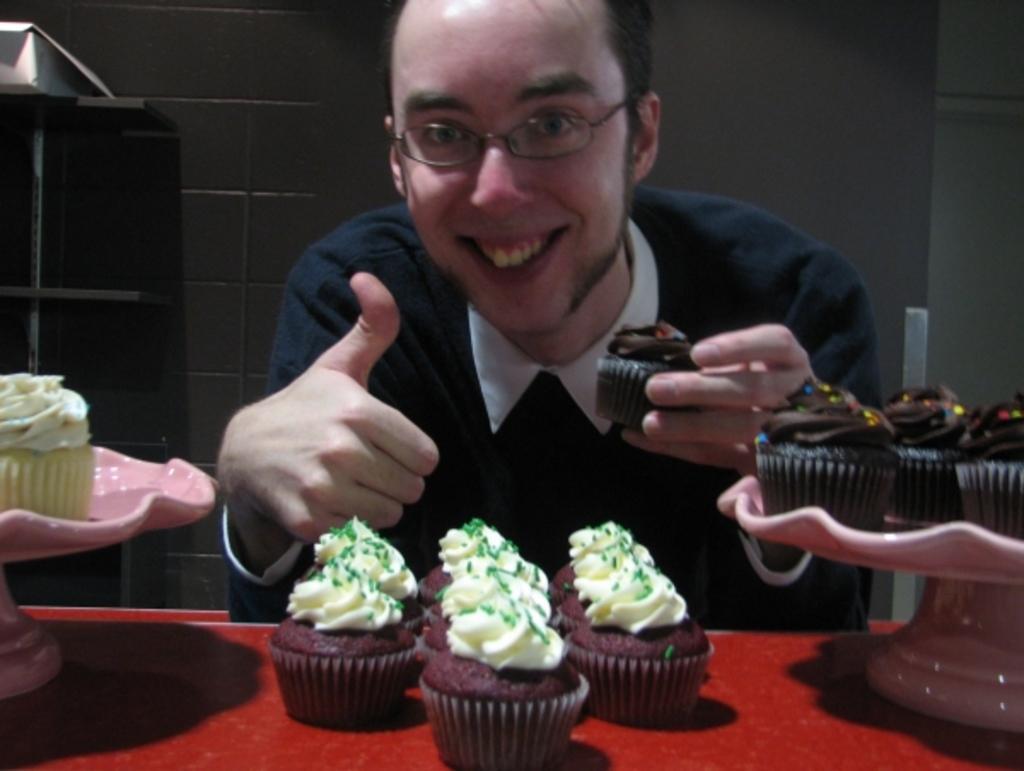Describe this image in one or two sentences. In this image in the center there is one man who is sitting and smiling, and he is holding an cupcakes. At the bottom there is a table, on the table there are group of cupcakes. In the background there is a wall. 